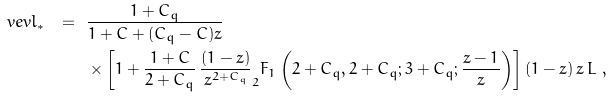<formula> <loc_0><loc_0><loc_500><loc_500>\ v e v { l _ { * } } \ = \ & \frac { 1 + C _ { q } } { 1 + C + ( C _ { q } - C ) z } \\ & \times \left [ 1 + \frac { 1 + C } { 2 + C _ { q } } \, \frac { ( 1 - z ) } { z ^ { 2 + C _ { q } } } _ { 2 } F _ { 1 } \left ( 2 + C _ { q } , 2 + C _ { q } ; 3 + C _ { q } ; \frac { z - 1 } { z } \right ) \right ] ( 1 - z ) \, z \, L \ ,</formula> 